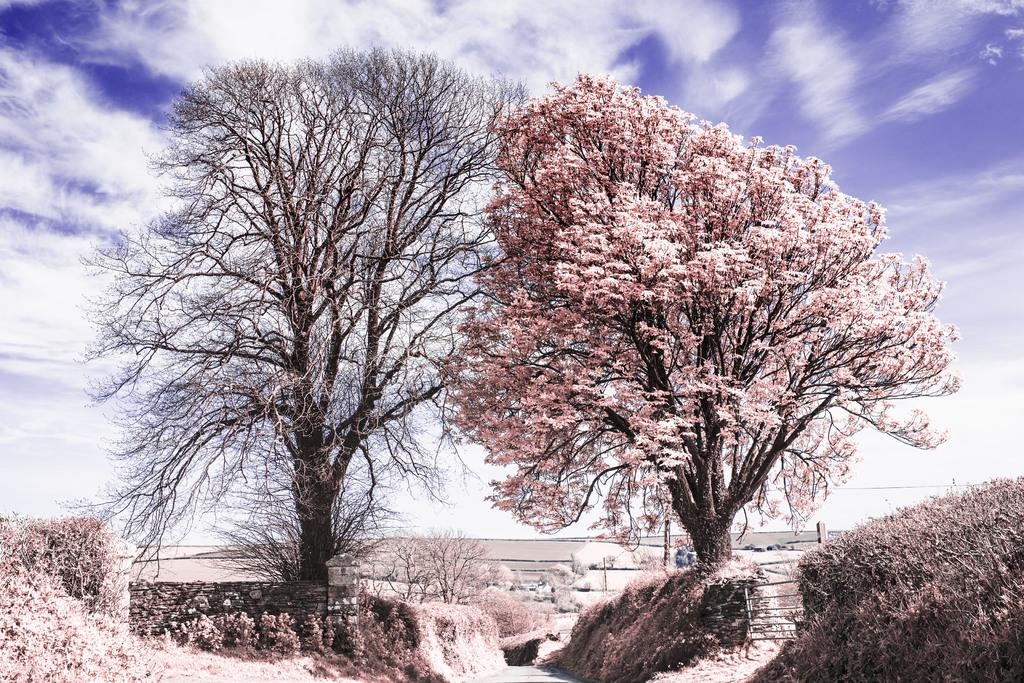What is located in the center of the image? There are trees in the center of the image. What can be seen in the background of the image? There appears to be a boundary in the background of the image. What type of chalk is being used to draw on the kitty in the image? There is no kitty or chalk present in the image. 